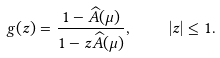Convert formula to latex. <formula><loc_0><loc_0><loc_500><loc_500>g ( z ) = \frac { 1 - \widehat { A } ( \mu ) } { 1 - z \widehat { A } ( \mu ) } , \quad | z | \leq 1 .</formula> 